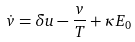Convert formula to latex. <formula><loc_0><loc_0><loc_500><loc_500>\dot { v } = \delta u - \frac { v } { T } + \kappa E _ { 0 }</formula> 